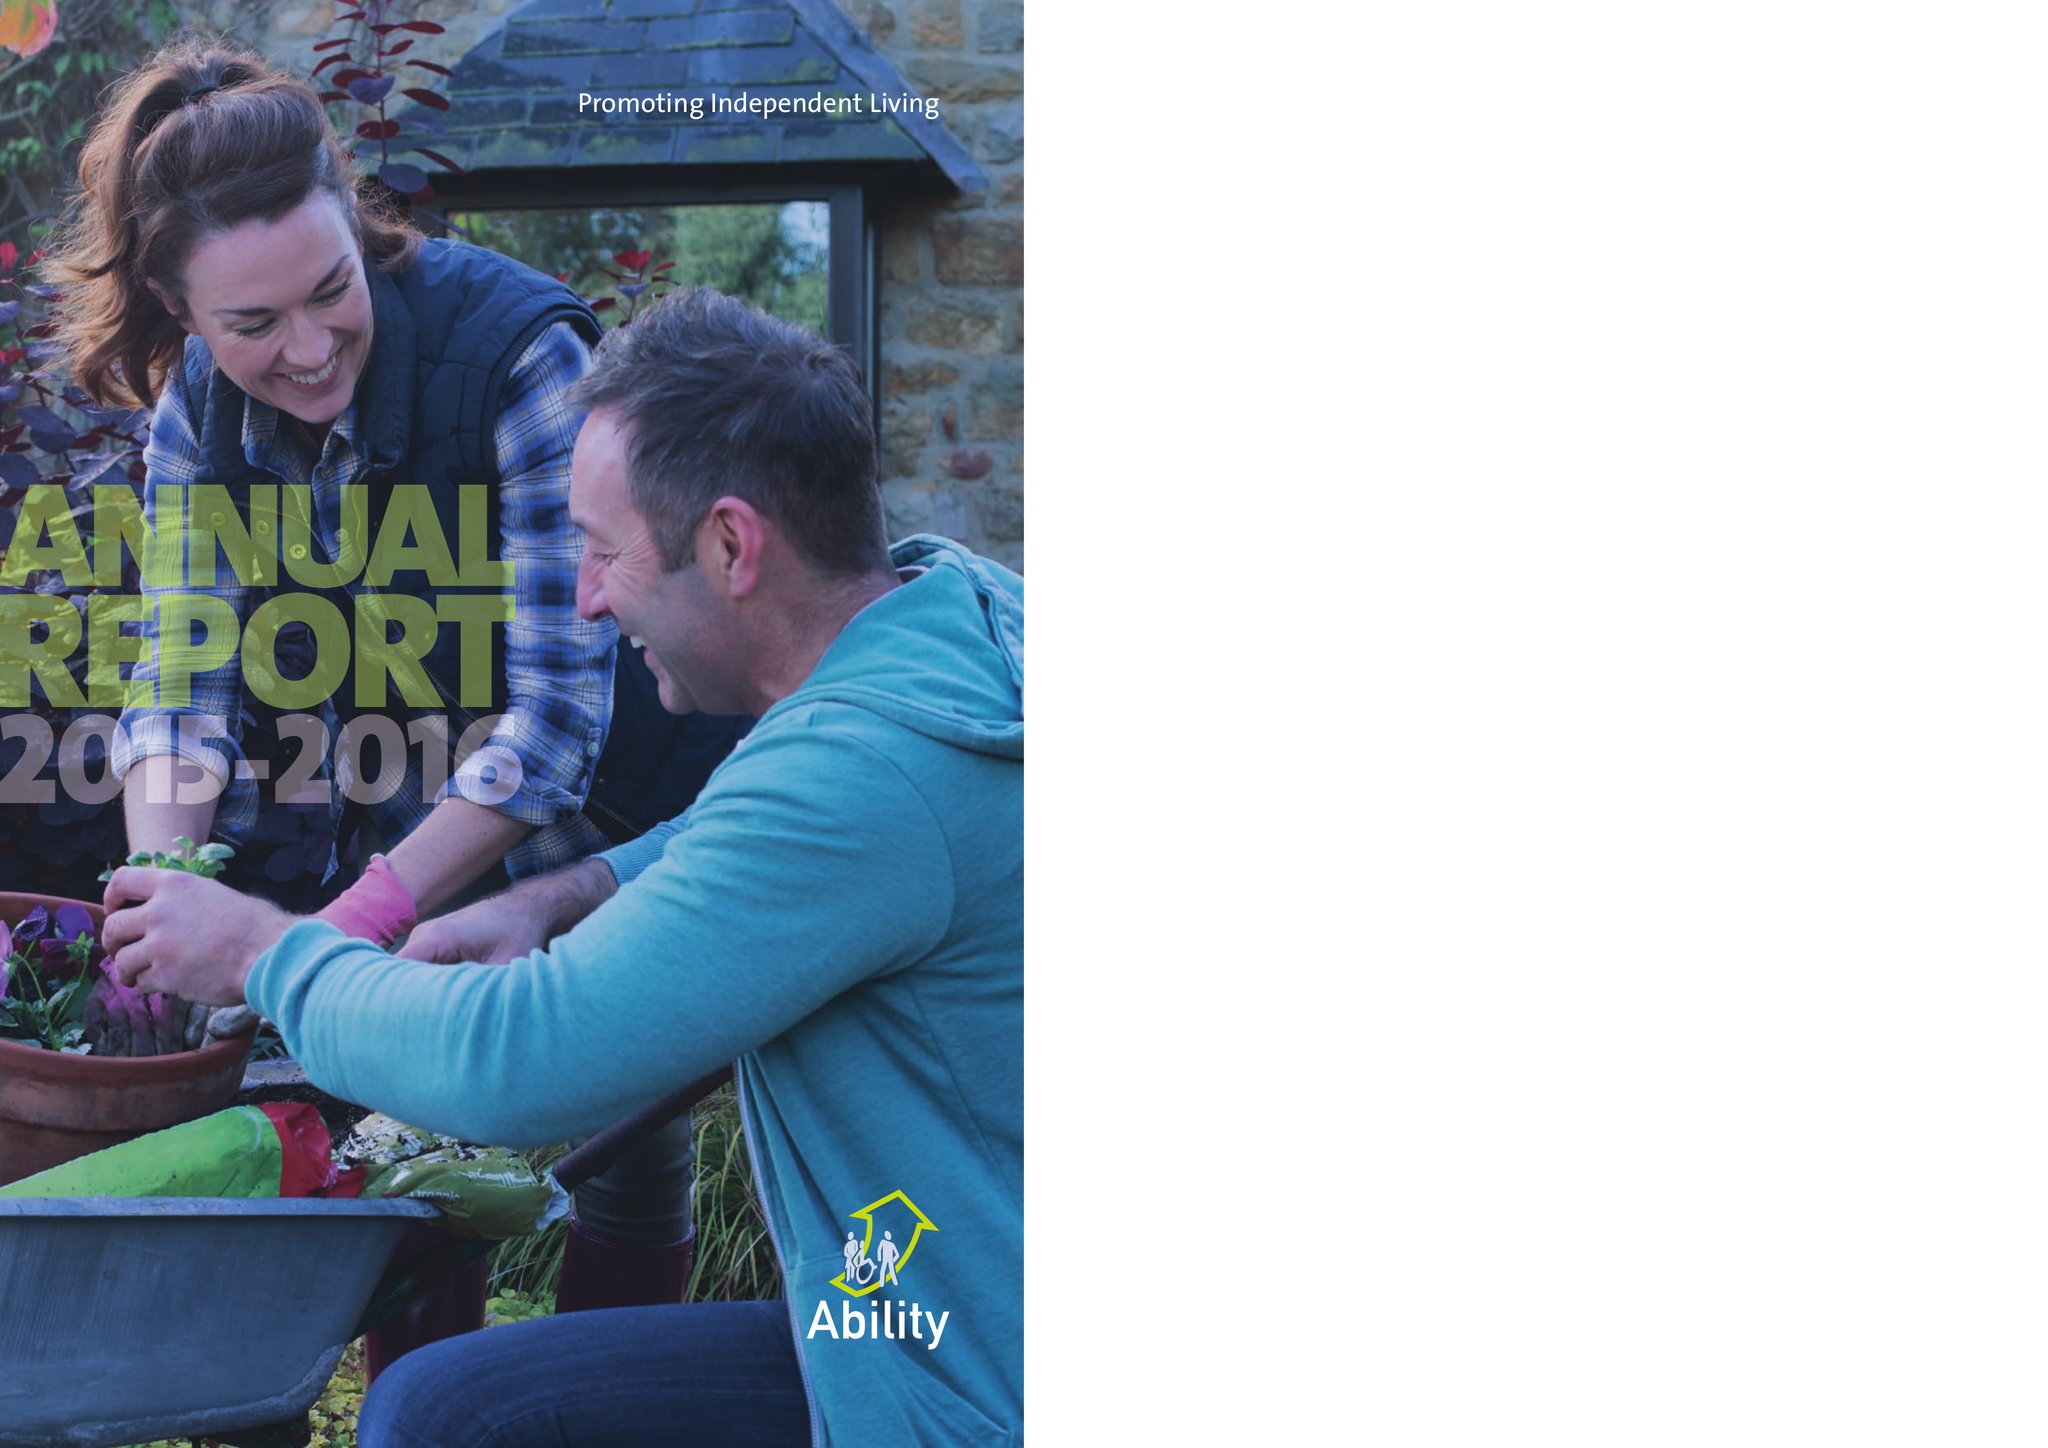What is the value for the address__postcode?
Answer the question using a single word or phrase. TW18 2AE 